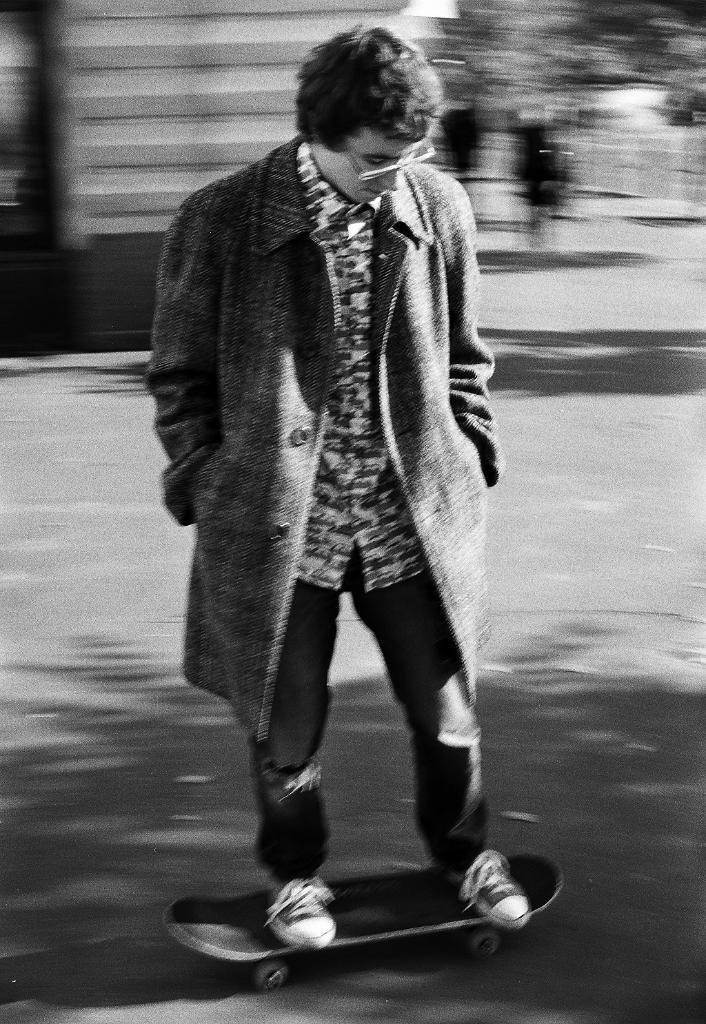Who is the main subject in the image? There is a man in the image. What is the man doing in the image? The man is on a skateboard. Can you describe the background of the image? The background of the image is blurred. What is the color scheme of the image? The image is in black and white. How many babies are wearing a crown in the image? There are no babies or crowns present in the image. What mathematical operation is being performed by the man on the skateboard in the image? There is no indication of any mathematical operation being performed in the image. 